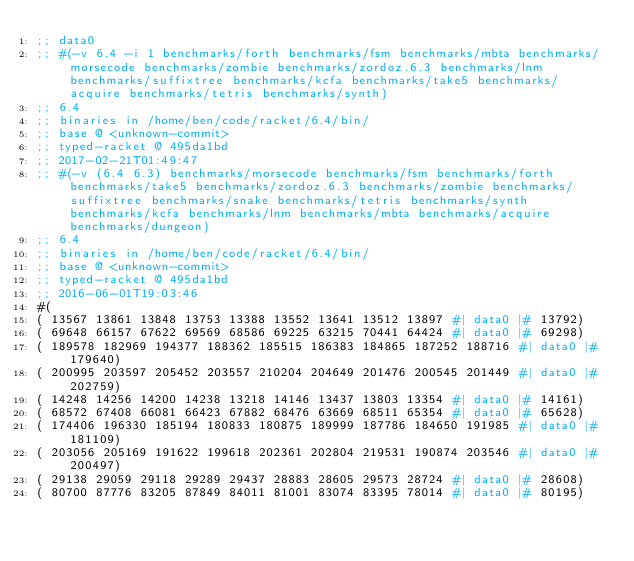<code> <loc_0><loc_0><loc_500><loc_500><_Racket_>;; data0
;; #(-v 6.4 -i 1 benchmarks/forth benchmarks/fsm benchmarks/mbta benchmarks/morsecode benchmarks/zombie benchmarks/zordoz.6.3 benchmarks/lnm benchmarks/suffixtree benchmarks/kcfa benchmarks/take5 benchmarks/acquire benchmarks/tetris benchmarks/synth)
;; 6.4
;; binaries in /home/ben/code/racket/6.4/bin/
;; base @ <unknown-commit>
;; typed-racket @ 495da1bd
;; 2017-02-21T01:49:47
;; #(-v (6.4 6.3) benchmarks/morsecode benchmarks/fsm benchmarks/forth benchmarks/take5 benchmarks/zordoz.6.3 benchmarks/zombie benchmarks/suffixtree benchmarks/snake benchmarks/tetris benchmarks/synth benchmarks/kcfa benchmarks/lnm benchmarks/mbta benchmarks/acquire benchmarks/dungeon)
;; 6.4
;; binaries in /home/ben/code/racket/6.4/bin/
;; base @ <unknown-commit>
;; typed-racket @ 495da1bd
;; 2016-06-01T19:03:46
#(
( 13567 13861 13848 13753 13388 13552 13641 13512 13897 #| data0 |# 13792)
( 69648 66157 67622 69569 68586 69225 63215 70441 64424 #| data0 |# 69298)
( 189578 182969 194377 188362 185515 186383 184865 187252 188716 #| data0 |# 179640)
( 200995 203597 205452 203557 210204 204649 201476 200545 201449 #| data0 |# 202759)
( 14248 14256 14200 14238 13218 14146 13437 13803 13354 #| data0 |# 14161)
( 68572 67408 66081 66423 67882 68476 63669 68511 65354 #| data0 |# 65628)
( 174406 196330 185194 180833 180875 189999 187786 184650 191985 #| data0 |# 181109)
( 203056 205169 191622 199618 202361 202804 219531 190874 203546 #| data0 |# 200497)
( 29138 29059 29118 29289 29437 28883 28605 29573 28724 #| data0 |# 28608)
( 80700 87776 83205 87849 84011 81001 83074 83395 78014 #| data0 |# 80195)</code> 